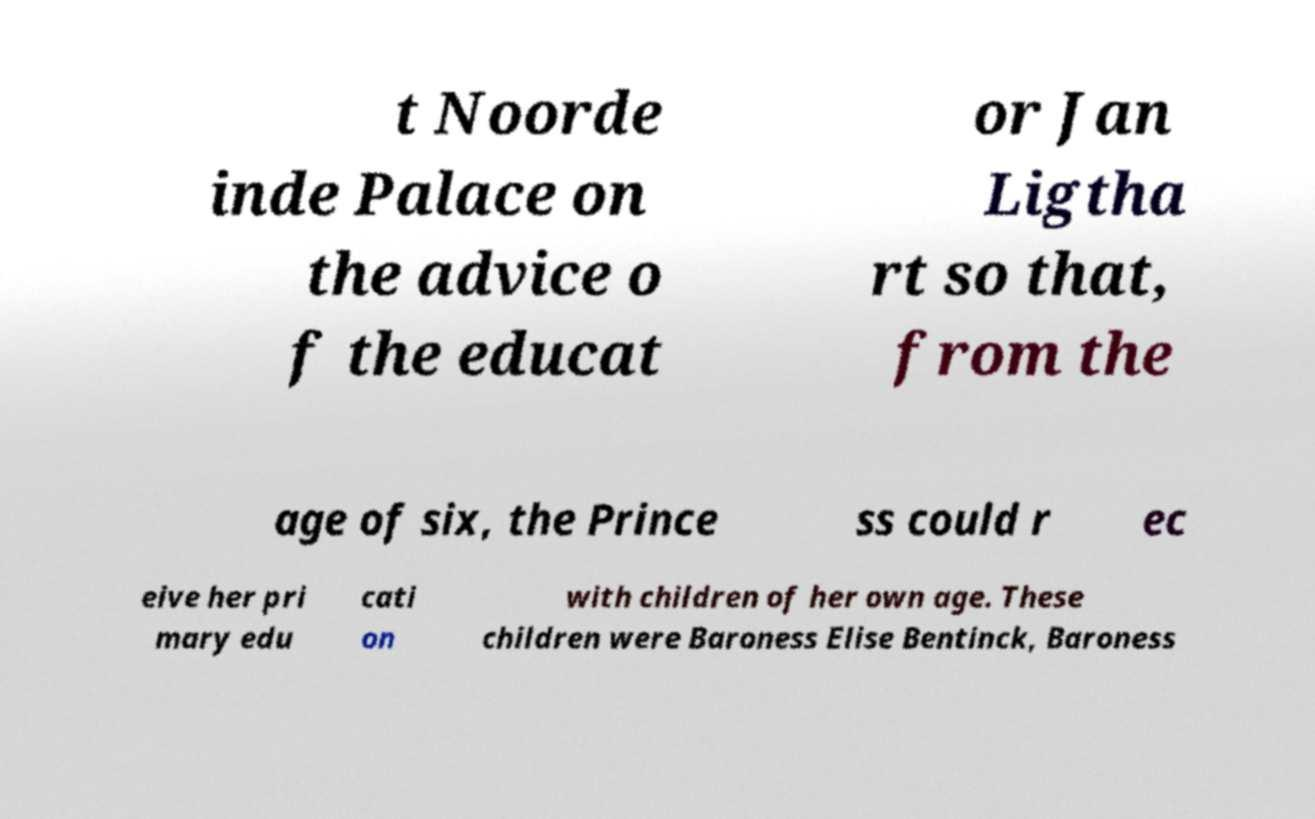Please identify and transcribe the text found in this image. t Noorde inde Palace on the advice o f the educat or Jan Ligtha rt so that, from the age of six, the Prince ss could r ec eive her pri mary edu cati on with children of her own age. These children were Baroness Elise Bentinck, Baroness 